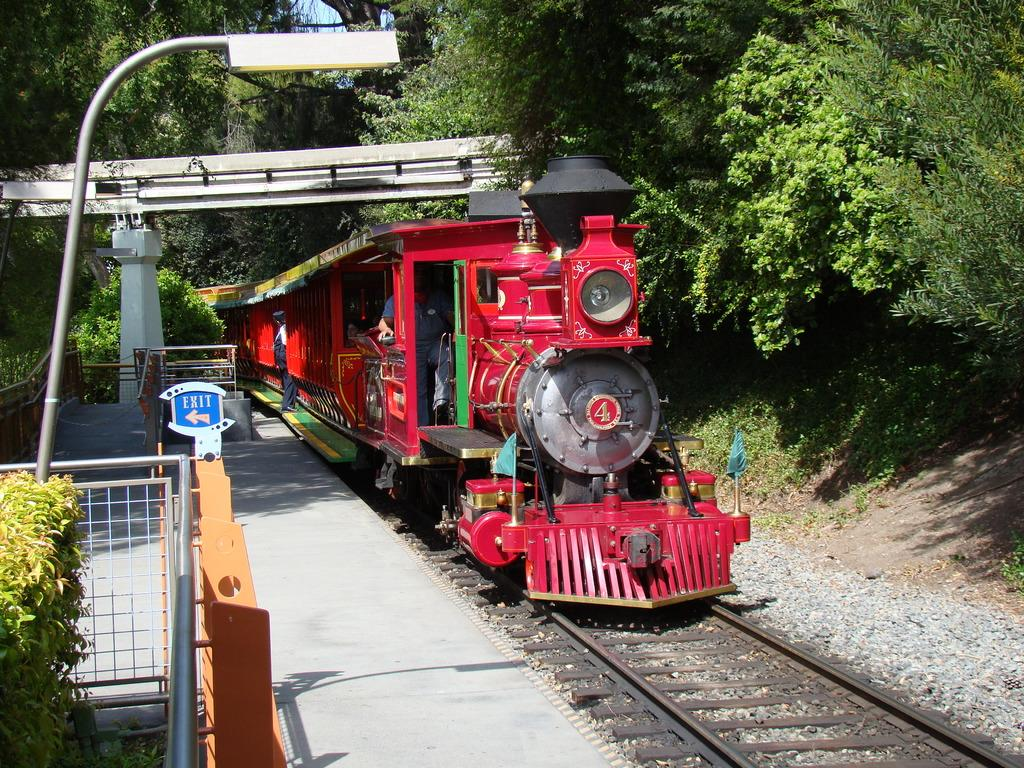What is the main subject of the image? The main subject of the image is a train. Where is the train located in the image? The train is on a railway track. What other structures or objects can be seen in the image? There is a platform, a pole, and a fence visible in the image. What can be seen in the background of the image? There are trees in the background of the image. What type of pan is being used to cook food on the train in the image? There is no pan or cooking activity visible in the image; it only shows a train on a railway track. 